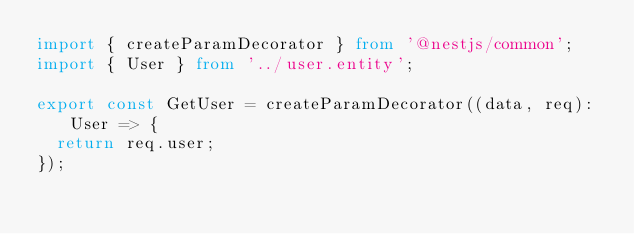<code> <loc_0><loc_0><loc_500><loc_500><_TypeScript_>import { createParamDecorator } from '@nestjs/common';
import { User } from '../user.entity';

export const GetUser = createParamDecorator((data, req): User => {
  return req.user;
});
</code> 